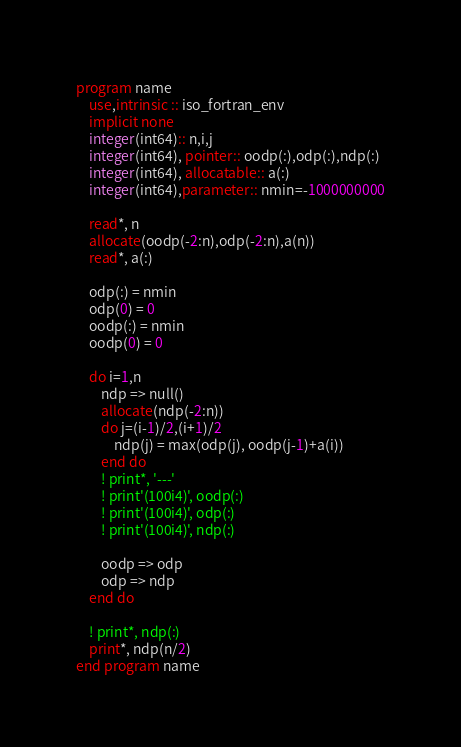Convert code to text. <code><loc_0><loc_0><loc_500><loc_500><_FORTRAN_>program name
    use,intrinsic :: iso_fortran_env
    implicit none
    integer(int64):: n,i,j
    integer(int64), pointer:: oodp(:),odp(:),ndp(:)
    integer(int64), allocatable:: a(:)
    integer(int64),parameter:: nmin=-1000000000

    read*, n
    allocate(oodp(-2:n),odp(-2:n),a(n))
    read*, a(:)

    odp(:) = nmin
    odp(0) = 0
    oodp(:) = nmin
    oodp(0) = 0

    do i=1,n
        ndp => null()
        allocate(ndp(-2:n))
        do j=(i-1)/2,(i+1)/2
            ndp(j) = max(odp(j), oodp(j-1)+a(i))
        end do
        ! print*, '---'
        ! print'(100i4)', oodp(:)
        ! print'(100i4)', odp(:)
        ! print'(100i4)', ndp(:)

        oodp => odp
        odp => ndp
    end do

    ! print*, ndp(:)
    print*, ndp(n/2)
end program name</code> 